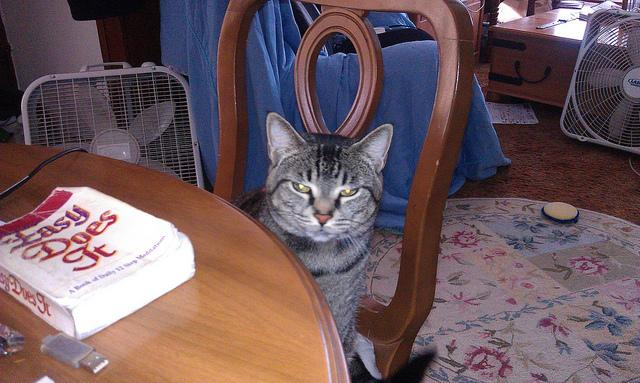The cat is sitting at a table with what featured on top of it? book 